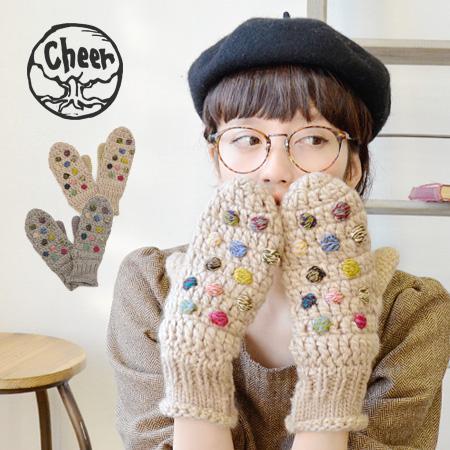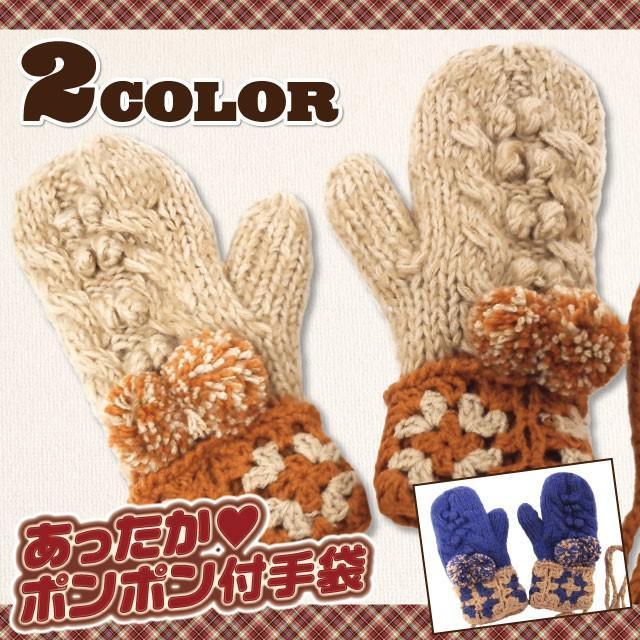The first image is the image on the left, the second image is the image on the right. For the images displayed, is the sentence "The model in one image wears a hat with animal ears and coordinating mittens." factually correct? Answer yes or no. No. 